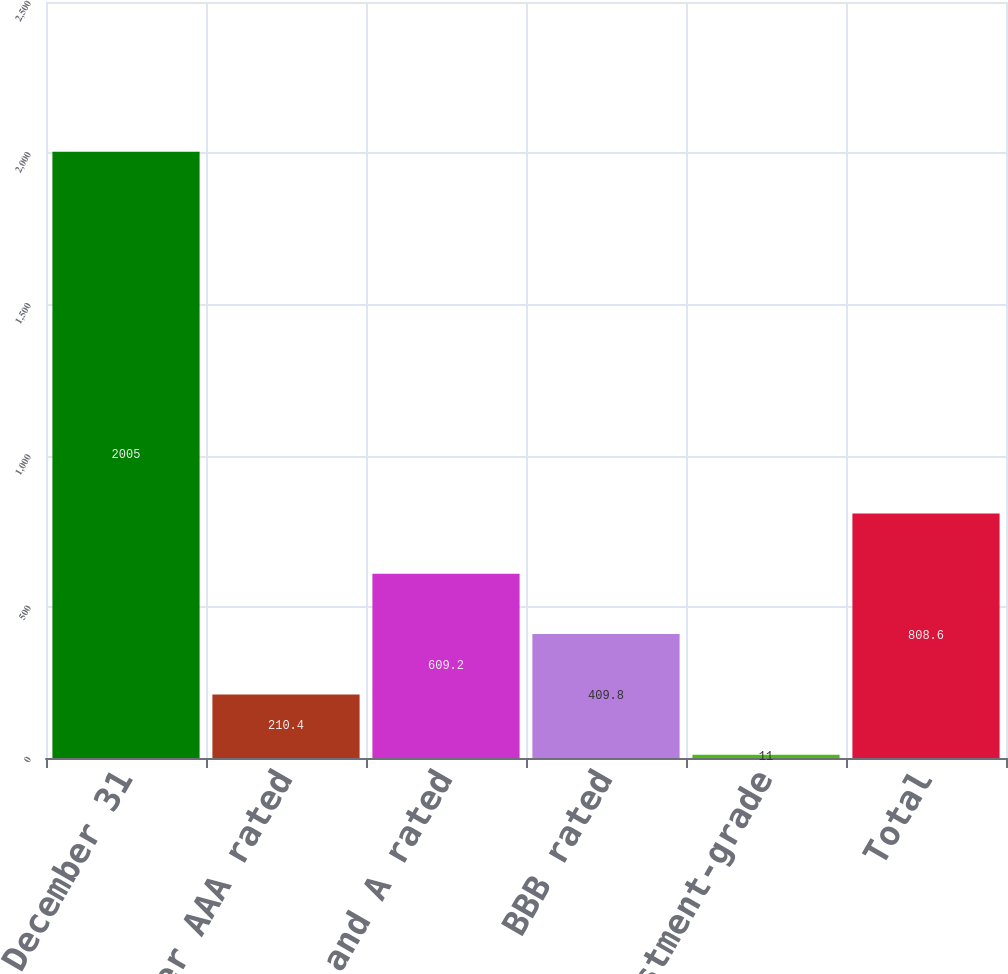Convert chart to OTSL. <chart><loc_0><loc_0><loc_500><loc_500><bar_chart><fcel>December 31<fcel>Other AAA rated<fcel>AA and A rated<fcel>BBB rated<fcel>Non investment-grade<fcel>Total<nl><fcel>2005<fcel>210.4<fcel>609.2<fcel>409.8<fcel>11<fcel>808.6<nl></chart> 